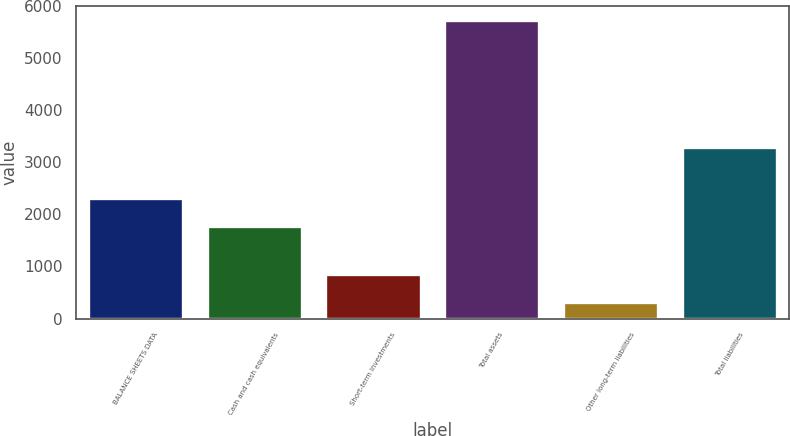<chart> <loc_0><loc_0><loc_500><loc_500><bar_chart><fcel>BALANCE SHEETS DATA<fcel>Cash and cash equivalents<fcel>Short-term investments<fcel>Total assets<fcel>Other long-term liabilities<fcel>Total liabilities<nl><fcel>2321.2<fcel>1782<fcel>863.2<fcel>5716<fcel>324<fcel>3294<nl></chart> 